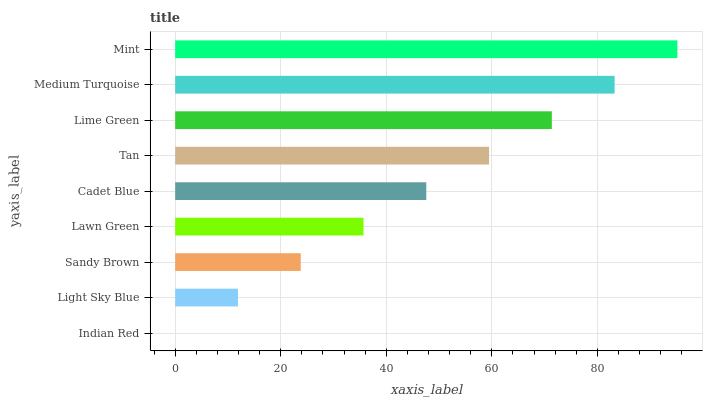Is Indian Red the minimum?
Answer yes or no. Yes. Is Mint the maximum?
Answer yes or no. Yes. Is Light Sky Blue the minimum?
Answer yes or no. No. Is Light Sky Blue the maximum?
Answer yes or no. No. Is Light Sky Blue greater than Indian Red?
Answer yes or no. Yes. Is Indian Red less than Light Sky Blue?
Answer yes or no. Yes. Is Indian Red greater than Light Sky Blue?
Answer yes or no. No. Is Light Sky Blue less than Indian Red?
Answer yes or no. No. Is Cadet Blue the high median?
Answer yes or no. Yes. Is Cadet Blue the low median?
Answer yes or no. Yes. Is Light Sky Blue the high median?
Answer yes or no. No. Is Tan the low median?
Answer yes or no. No. 